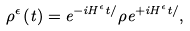<formula> <loc_0><loc_0><loc_500><loc_500>\rho ^ { \epsilon } \left ( t \right ) = e ^ { - i H ^ { \epsilon } t / } \rho e ^ { + i H ^ { \epsilon } t / } ,</formula> 